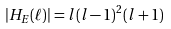Convert formula to latex. <formula><loc_0><loc_0><loc_500><loc_500>| H _ { E } ( \ell ) | = l ( l - 1 ) ^ { 2 } ( l + 1 )</formula> 